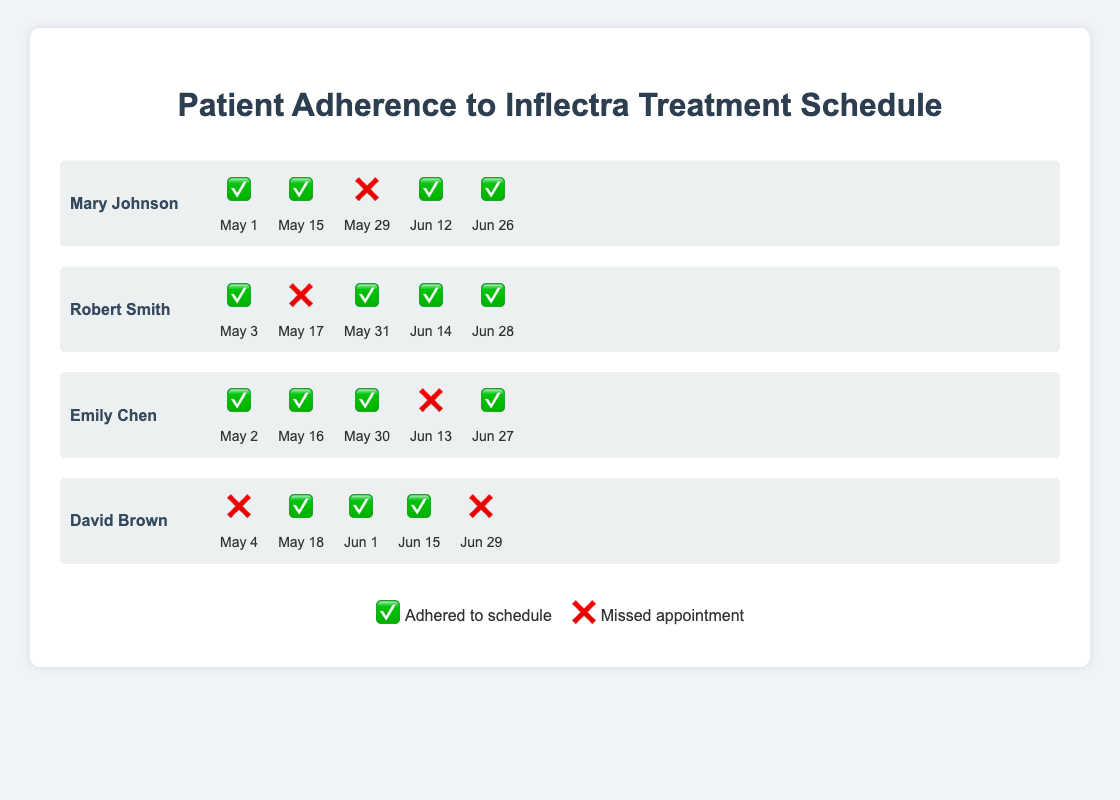Which patient had the most missed appointments? Reviewing the visual information for each patient: Mary Johnson missed 1 appointment (❌ on May 29), Robert Smith missed 1 appointment (❌ on May 17), Emily Chen missed 1 appointment (❌ on June 13), and David Brown missed 2 appointments (❌ on May 4 and June 29). David Brown has the most missed appointments.
Answer: David Brown How many patients adhered to all their June appointments? For June appointments, Mary Johnson (✅ on June 12 and June 26), Robert Smith (✅ on June 14 and June 28), Emily Chen (❌ on June 13, ✅ on June 27), and David Brown (✅ on June 1 and June 15, ❌ on June 29), only Mary Johnson and Robert Smith adhered to all their June appointments.
Answer: 2 Who adhered to all their May appointments? Reviewing the visual information for May appointments only: Mary Johnson (✅ on May 1 and May 15, ❌ on May 29), Robert Smith (✅ on May 3, ❌ on May 17, ✅ on May 31), Emily Chen (✅ on May 2, May 16, and May 30), David Brown (❌ on May 4, ✅ on May 18). Only Emily Chen adhered to all their May appointments.
Answer: Emily Chen Which dates did Mary Johnson miss her appointments? Reviewing Mary Johnson's adherence status: the missed appointment (❌) is on May 29.
Answer: May 29 Who has the highest appointment adherence rate? Calculating adherence rate involves dividing the number of adhered appointments (✅) by the total number of appointments (5): Mary Johnson (4/5), Robert Smith (4/5), Emily Chen (4/5), and David Brown (3/5). Mary Johnson, Robert Smith, and Emily Chen have the highest adherence rate of 4/5 (or 80%).
Answer: Mary Johnson, Robert Smith, Emily Chen On which date did the highest number of patients miss their appointment? Review each date and count the number of missed appointments (❌): May 29 (Mary Johnson), May 17 (Robert Smith), June 13 (Emily Chen), May 4 and June 29 (David Brown). Only David Brown missed appointments on May 4 and June 29, no other dates had multiple patients missing. Thus, no single date had multiple missed appointments.
Answer: None How many appointments did Robert Smith miss in total? Count the ❌ for Robert Smith. He missed one on May 17.
Answer: 1 How many patients have a perfect adherence record? A perfect adherence record is reflected with all ✅ entries: None of Mary Johnson, Robert Smith, Emily Chen, or David Brown has all ✅.
Answer: 0 